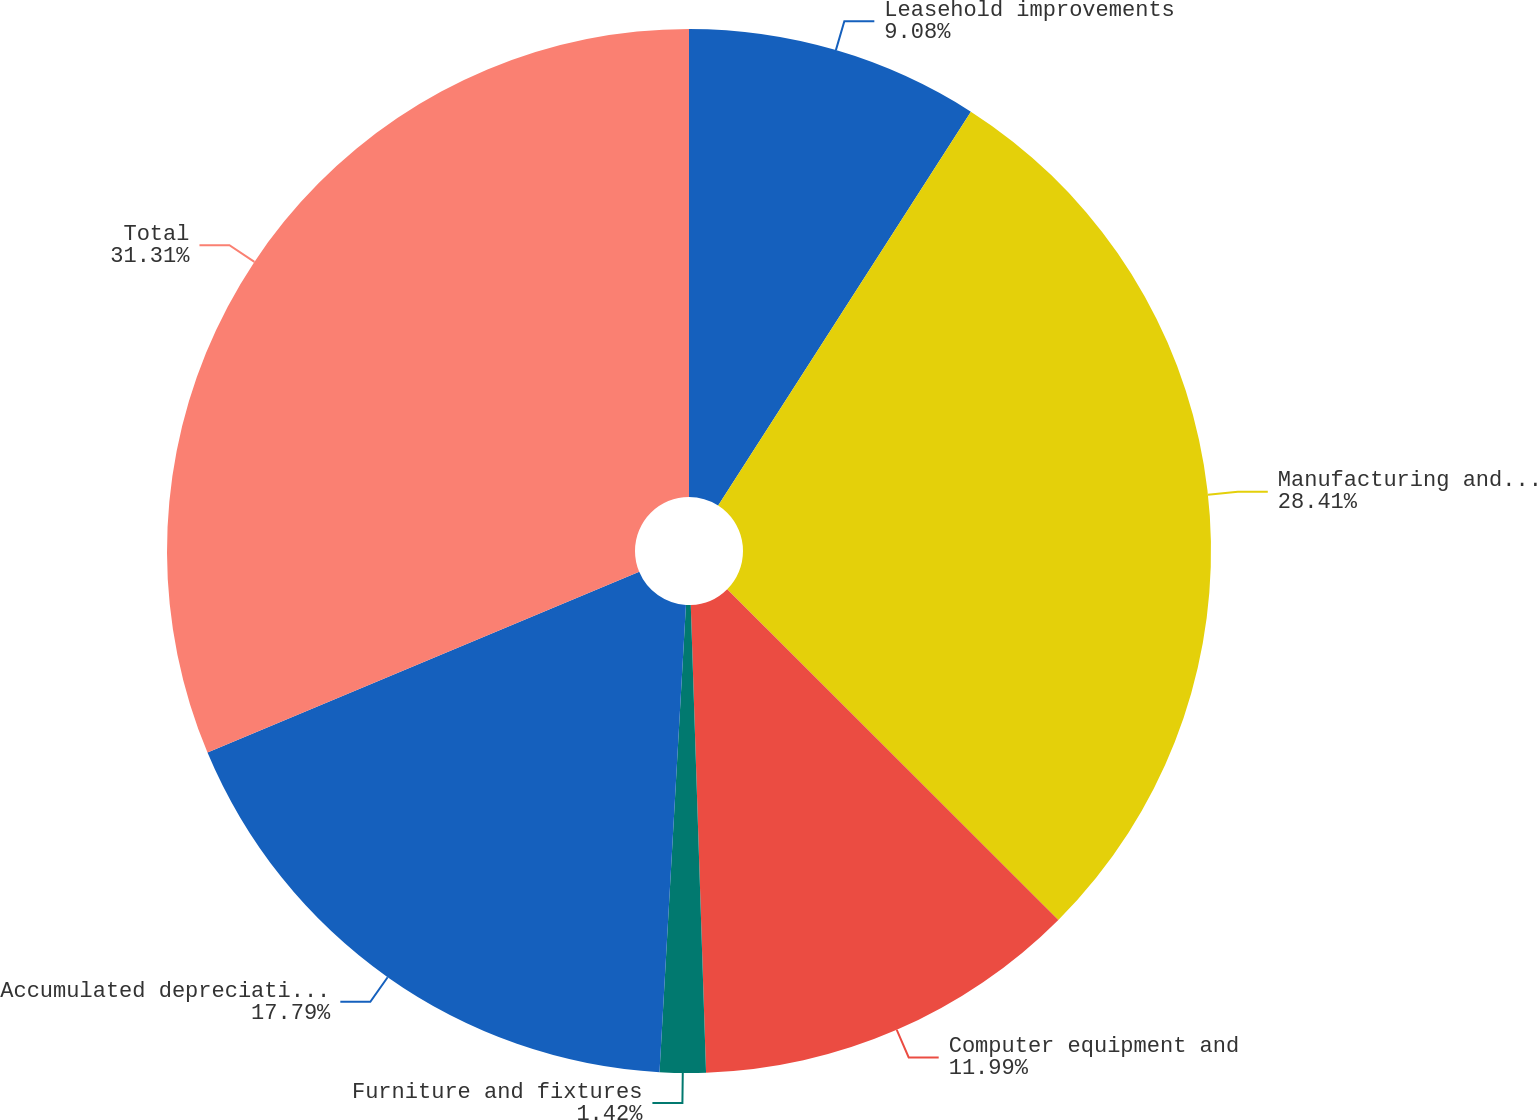Convert chart to OTSL. <chart><loc_0><loc_0><loc_500><loc_500><pie_chart><fcel>Leasehold improvements<fcel>Manufacturing and laboratory<fcel>Computer equipment and<fcel>Furniture and fixtures<fcel>Accumulated depreciation and<fcel>Total<nl><fcel>9.08%<fcel>28.41%<fcel>11.99%<fcel>1.42%<fcel>17.79%<fcel>31.31%<nl></chart> 